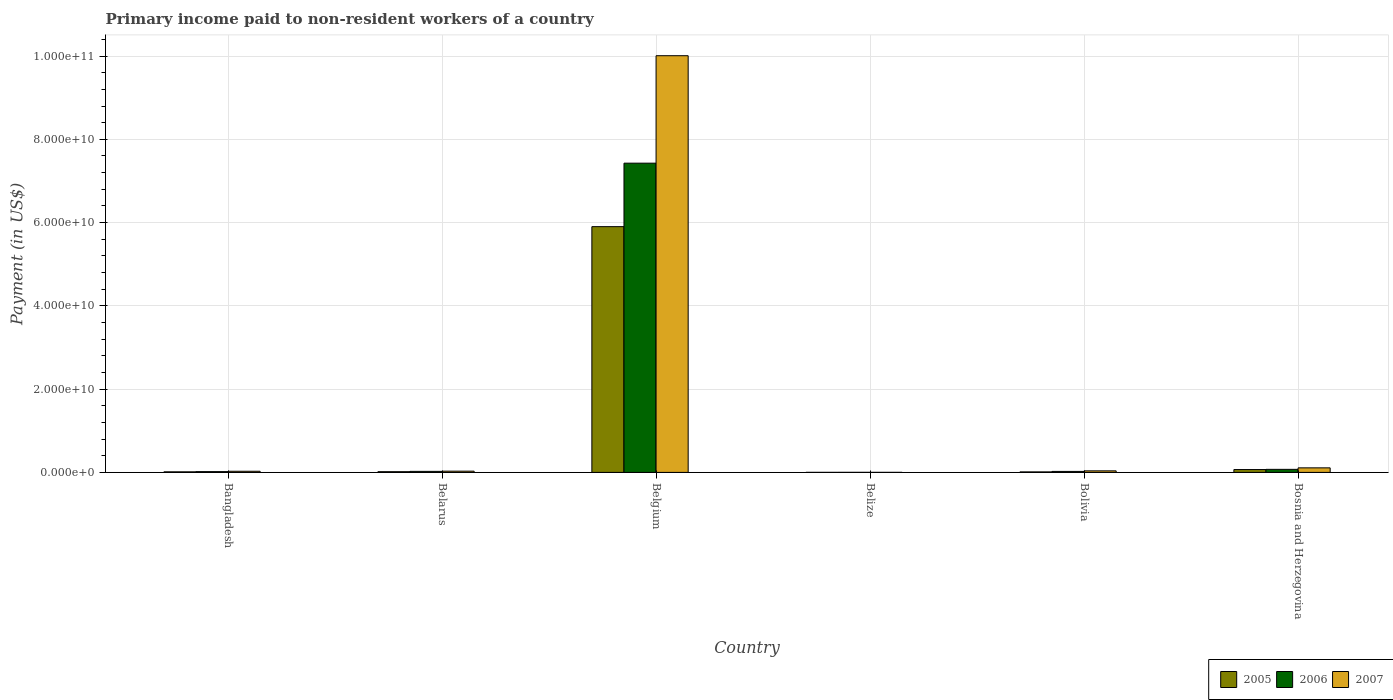How many different coloured bars are there?
Provide a succinct answer. 3. How many bars are there on the 4th tick from the left?
Offer a terse response. 3. How many bars are there on the 4th tick from the right?
Ensure brevity in your answer.  3. In how many cases, is the number of bars for a given country not equal to the number of legend labels?
Your response must be concise. 0. What is the amount paid to workers in 2007 in Bangladesh?
Your response must be concise. 2.72e+08. Across all countries, what is the maximum amount paid to workers in 2007?
Offer a very short reply. 1.00e+11. Across all countries, what is the minimum amount paid to workers in 2007?
Your response must be concise. 6.97e+06. In which country was the amount paid to workers in 2005 maximum?
Your answer should be very brief. Belgium. In which country was the amount paid to workers in 2005 minimum?
Your answer should be compact. Belize. What is the total amount paid to workers in 2007 in the graph?
Your response must be concise. 1.02e+11. What is the difference between the amount paid to workers in 2007 in Belize and that in Bolivia?
Ensure brevity in your answer.  -3.63e+08. What is the difference between the amount paid to workers in 2005 in Bolivia and the amount paid to workers in 2007 in Belarus?
Offer a terse response. -1.76e+08. What is the average amount paid to workers in 2006 per country?
Provide a short and direct response. 1.26e+1. What is the difference between the amount paid to workers of/in 2005 and amount paid to workers of/in 2007 in Bosnia and Herzegovina?
Make the answer very short. -4.10e+08. What is the ratio of the amount paid to workers in 2005 in Belarus to that in Bosnia and Herzegovina?
Provide a short and direct response. 0.25. Is the difference between the amount paid to workers in 2005 in Belgium and Bolivia greater than the difference between the amount paid to workers in 2007 in Belgium and Bolivia?
Your response must be concise. No. What is the difference between the highest and the second highest amount paid to workers in 2006?
Ensure brevity in your answer.  -7.40e+1. What is the difference between the highest and the lowest amount paid to workers in 2007?
Provide a succinct answer. 1.00e+11. Is the sum of the amount paid to workers in 2006 in Bolivia and Bosnia and Herzegovina greater than the maximum amount paid to workers in 2005 across all countries?
Offer a terse response. No. What does the 2nd bar from the left in Belarus represents?
Offer a terse response. 2006. Is it the case that in every country, the sum of the amount paid to workers in 2005 and amount paid to workers in 2006 is greater than the amount paid to workers in 2007?
Keep it short and to the point. No. How many bars are there?
Your answer should be compact. 18. Are all the bars in the graph horizontal?
Offer a very short reply. No. Does the graph contain any zero values?
Give a very brief answer. No. Does the graph contain grids?
Keep it short and to the point. Yes. What is the title of the graph?
Provide a short and direct response. Primary income paid to non-resident workers of a country. Does "1987" appear as one of the legend labels in the graph?
Your response must be concise. No. What is the label or title of the X-axis?
Give a very brief answer. Country. What is the label or title of the Y-axis?
Your answer should be very brief. Payment (in US$). What is the Payment (in US$) in 2005 in Bangladesh?
Your response must be concise. 1.35e+08. What is the Payment (in US$) in 2006 in Bangladesh?
Keep it short and to the point. 1.84e+08. What is the Payment (in US$) in 2007 in Bangladesh?
Your response must be concise. 2.72e+08. What is the Payment (in US$) of 2005 in Belarus?
Your answer should be compact. 1.68e+08. What is the Payment (in US$) in 2006 in Belarus?
Ensure brevity in your answer.  2.47e+08. What is the Payment (in US$) of 2007 in Belarus?
Provide a succinct answer. 2.97e+08. What is the Payment (in US$) of 2005 in Belgium?
Your answer should be very brief. 5.90e+1. What is the Payment (in US$) of 2006 in Belgium?
Your answer should be very brief. 7.43e+1. What is the Payment (in US$) of 2007 in Belgium?
Your answer should be compact. 1.00e+11. What is the Payment (in US$) of 2005 in Belize?
Your response must be concise. 6.78e+06. What is the Payment (in US$) of 2006 in Belize?
Provide a succinct answer. 1.01e+07. What is the Payment (in US$) of 2007 in Belize?
Your response must be concise. 6.97e+06. What is the Payment (in US$) in 2005 in Bolivia?
Keep it short and to the point. 1.21e+08. What is the Payment (in US$) in 2006 in Bolivia?
Provide a short and direct response. 2.35e+08. What is the Payment (in US$) of 2007 in Bolivia?
Provide a succinct answer. 3.70e+08. What is the Payment (in US$) of 2005 in Bosnia and Herzegovina?
Make the answer very short. 6.82e+08. What is the Payment (in US$) in 2006 in Bosnia and Herzegovina?
Offer a very short reply. 7.33e+08. What is the Payment (in US$) of 2007 in Bosnia and Herzegovina?
Give a very brief answer. 1.09e+09. Across all countries, what is the maximum Payment (in US$) of 2005?
Provide a succinct answer. 5.90e+1. Across all countries, what is the maximum Payment (in US$) in 2006?
Keep it short and to the point. 7.43e+1. Across all countries, what is the maximum Payment (in US$) of 2007?
Offer a very short reply. 1.00e+11. Across all countries, what is the minimum Payment (in US$) of 2005?
Give a very brief answer. 6.78e+06. Across all countries, what is the minimum Payment (in US$) in 2006?
Your answer should be very brief. 1.01e+07. Across all countries, what is the minimum Payment (in US$) in 2007?
Make the answer very short. 6.97e+06. What is the total Payment (in US$) of 2005 in the graph?
Offer a terse response. 6.01e+1. What is the total Payment (in US$) of 2006 in the graph?
Your answer should be compact. 7.57e+1. What is the total Payment (in US$) of 2007 in the graph?
Keep it short and to the point. 1.02e+11. What is the difference between the Payment (in US$) of 2005 in Bangladesh and that in Belarus?
Provide a succinct answer. -3.32e+07. What is the difference between the Payment (in US$) in 2006 in Bangladesh and that in Belarus?
Offer a terse response. -6.22e+07. What is the difference between the Payment (in US$) in 2007 in Bangladesh and that in Belarus?
Your answer should be compact. -2.54e+07. What is the difference between the Payment (in US$) of 2005 in Bangladesh and that in Belgium?
Give a very brief answer. -5.89e+1. What is the difference between the Payment (in US$) in 2006 in Bangladesh and that in Belgium?
Give a very brief answer. -7.41e+1. What is the difference between the Payment (in US$) of 2007 in Bangladesh and that in Belgium?
Ensure brevity in your answer.  -9.98e+1. What is the difference between the Payment (in US$) of 2005 in Bangladesh and that in Belize?
Offer a terse response. 1.28e+08. What is the difference between the Payment (in US$) of 2006 in Bangladesh and that in Belize?
Make the answer very short. 1.74e+08. What is the difference between the Payment (in US$) of 2007 in Bangladesh and that in Belize?
Ensure brevity in your answer.  2.65e+08. What is the difference between the Payment (in US$) of 2005 in Bangladesh and that in Bolivia?
Offer a very short reply. 1.39e+07. What is the difference between the Payment (in US$) in 2006 in Bangladesh and that in Bolivia?
Offer a terse response. -5.10e+07. What is the difference between the Payment (in US$) of 2007 in Bangladesh and that in Bolivia?
Offer a terse response. -9.81e+07. What is the difference between the Payment (in US$) of 2005 in Bangladesh and that in Bosnia and Herzegovina?
Ensure brevity in your answer.  -5.47e+08. What is the difference between the Payment (in US$) in 2006 in Bangladesh and that in Bosnia and Herzegovina?
Offer a terse response. -5.48e+08. What is the difference between the Payment (in US$) of 2007 in Bangladesh and that in Bosnia and Herzegovina?
Offer a terse response. -8.20e+08. What is the difference between the Payment (in US$) of 2005 in Belarus and that in Belgium?
Your answer should be compact. -5.89e+1. What is the difference between the Payment (in US$) in 2006 in Belarus and that in Belgium?
Ensure brevity in your answer.  -7.40e+1. What is the difference between the Payment (in US$) of 2007 in Belarus and that in Belgium?
Provide a short and direct response. -9.98e+1. What is the difference between the Payment (in US$) of 2005 in Belarus and that in Belize?
Offer a very short reply. 1.62e+08. What is the difference between the Payment (in US$) in 2006 in Belarus and that in Belize?
Ensure brevity in your answer.  2.36e+08. What is the difference between the Payment (in US$) of 2007 in Belarus and that in Belize?
Provide a short and direct response. 2.90e+08. What is the difference between the Payment (in US$) of 2005 in Belarus and that in Bolivia?
Ensure brevity in your answer.  4.72e+07. What is the difference between the Payment (in US$) of 2006 in Belarus and that in Bolivia?
Offer a very short reply. 1.12e+07. What is the difference between the Payment (in US$) in 2007 in Belarus and that in Bolivia?
Offer a terse response. -7.27e+07. What is the difference between the Payment (in US$) in 2005 in Belarus and that in Bosnia and Herzegovina?
Keep it short and to the point. -5.14e+08. What is the difference between the Payment (in US$) of 2006 in Belarus and that in Bosnia and Herzegovina?
Keep it short and to the point. -4.86e+08. What is the difference between the Payment (in US$) of 2007 in Belarus and that in Bosnia and Herzegovina?
Give a very brief answer. -7.95e+08. What is the difference between the Payment (in US$) in 2005 in Belgium and that in Belize?
Your answer should be compact. 5.90e+1. What is the difference between the Payment (in US$) of 2006 in Belgium and that in Belize?
Provide a succinct answer. 7.43e+1. What is the difference between the Payment (in US$) in 2007 in Belgium and that in Belize?
Ensure brevity in your answer.  1.00e+11. What is the difference between the Payment (in US$) in 2005 in Belgium and that in Bolivia?
Provide a succinct answer. 5.89e+1. What is the difference between the Payment (in US$) in 2006 in Belgium and that in Bolivia?
Make the answer very short. 7.40e+1. What is the difference between the Payment (in US$) of 2007 in Belgium and that in Bolivia?
Provide a short and direct response. 9.97e+1. What is the difference between the Payment (in US$) in 2005 in Belgium and that in Bosnia and Herzegovina?
Your answer should be very brief. 5.83e+1. What is the difference between the Payment (in US$) of 2006 in Belgium and that in Bosnia and Herzegovina?
Your response must be concise. 7.35e+1. What is the difference between the Payment (in US$) of 2007 in Belgium and that in Bosnia and Herzegovina?
Your answer should be very brief. 9.90e+1. What is the difference between the Payment (in US$) in 2005 in Belize and that in Bolivia?
Give a very brief answer. -1.14e+08. What is the difference between the Payment (in US$) of 2006 in Belize and that in Bolivia?
Provide a short and direct response. -2.25e+08. What is the difference between the Payment (in US$) of 2007 in Belize and that in Bolivia?
Make the answer very short. -3.63e+08. What is the difference between the Payment (in US$) of 2005 in Belize and that in Bosnia and Herzegovina?
Give a very brief answer. -6.76e+08. What is the difference between the Payment (in US$) of 2006 in Belize and that in Bosnia and Herzegovina?
Keep it short and to the point. -7.22e+08. What is the difference between the Payment (in US$) of 2007 in Belize and that in Bosnia and Herzegovina?
Offer a terse response. -1.08e+09. What is the difference between the Payment (in US$) of 2005 in Bolivia and that in Bosnia and Herzegovina?
Your answer should be compact. -5.61e+08. What is the difference between the Payment (in US$) of 2006 in Bolivia and that in Bosnia and Herzegovina?
Ensure brevity in your answer.  -4.97e+08. What is the difference between the Payment (in US$) of 2007 in Bolivia and that in Bosnia and Herzegovina?
Your response must be concise. -7.22e+08. What is the difference between the Payment (in US$) of 2005 in Bangladesh and the Payment (in US$) of 2006 in Belarus?
Give a very brief answer. -1.11e+08. What is the difference between the Payment (in US$) in 2005 in Bangladesh and the Payment (in US$) in 2007 in Belarus?
Make the answer very short. -1.62e+08. What is the difference between the Payment (in US$) in 2006 in Bangladesh and the Payment (in US$) in 2007 in Belarus?
Ensure brevity in your answer.  -1.13e+08. What is the difference between the Payment (in US$) of 2005 in Bangladesh and the Payment (in US$) of 2006 in Belgium?
Offer a terse response. -7.41e+1. What is the difference between the Payment (in US$) in 2005 in Bangladesh and the Payment (in US$) in 2007 in Belgium?
Give a very brief answer. -1.00e+11. What is the difference between the Payment (in US$) of 2006 in Bangladesh and the Payment (in US$) of 2007 in Belgium?
Provide a short and direct response. -9.99e+1. What is the difference between the Payment (in US$) in 2005 in Bangladesh and the Payment (in US$) in 2006 in Belize?
Your answer should be compact. 1.25e+08. What is the difference between the Payment (in US$) in 2005 in Bangladesh and the Payment (in US$) in 2007 in Belize?
Make the answer very short. 1.28e+08. What is the difference between the Payment (in US$) in 2006 in Bangladesh and the Payment (in US$) in 2007 in Belize?
Offer a terse response. 1.77e+08. What is the difference between the Payment (in US$) in 2005 in Bangladesh and the Payment (in US$) in 2006 in Bolivia?
Make the answer very short. -1.00e+08. What is the difference between the Payment (in US$) in 2005 in Bangladesh and the Payment (in US$) in 2007 in Bolivia?
Keep it short and to the point. -2.35e+08. What is the difference between the Payment (in US$) in 2006 in Bangladesh and the Payment (in US$) in 2007 in Bolivia?
Give a very brief answer. -1.85e+08. What is the difference between the Payment (in US$) of 2005 in Bangladesh and the Payment (in US$) of 2006 in Bosnia and Herzegovina?
Keep it short and to the point. -5.97e+08. What is the difference between the Payment (in US$) of 2005 in Bangladesh and the Payment (in US$) of 2007 in Bosnia and Herzegovina?
Your response must be concise. -9.57e+08. What is the difference between the Payment (in US$) in 2006 in Bangladesh and the Payment (in US$) in 2007 in Bosnia and Herzegovina?
Offer a terse response. -9.07e+08. What is the difference between the Payment (in US$) in 2005 in Belarus and the Payment (in US$) in 2006 in Belgium?
Provide a short and direct response. -7.41e+1. What is the difference between the Payment (in US$) in 2005 in Belarus and the Payment (in US$) in 2007 in Belgium?
Offer a very short reply. -9.99e+1. What is the difference between the Payment (in US$) of 2006 in Belarus and the Payment (in US$) of 2007 in Belgium?
Ensure brevity in your answer.  -9.98e+1. What is the difference between the Payment (in US$) of 2005 in Belarus and the Payment (in US$) of 2006 in Belize?
Make the answer very short. 1.58e+08. What is the difference between the Payment (in US$) of 2005 in Belarus and the Payment (in US$) of 2007 in Belize?
Your answer should be very brief. 1.61e+08. What is the difference between the Payment (in US$) of 2006 in Belarus and the Payment (in US$) of 2007 in Belize?
Keep it short and to the point. 2.40e+08. What is the difference between the Payment (in US$) in 2005 in Belarus and the Payment (in US$) in 2006 in Bolivia?
Offer a terse response. -6.70e+07. What is the difference between the Payment (in US$) in 2005 in Belarus and the Payment (in US$) in 2007 in Bolivia?
Provide a succinct answer. -2.01e+08. What is the difference between the Payment (in US$) of 2006 in Belarus and the Payment (in US$) of 2007 in Bolivia?
Ensure brevity in your answer.  -1.23e+08. What is the difference between the Payment (in US$) in 2005 in Belarus and the Payment (in US$) in 2006 in Bosnia and Herzegovina?
Keep it short and to the point. -5.64e+08. What is the difference between the Payment (in US$) in 2005 in Belarus and the Payment (in US$) in 2007 in Bosnia and Herzegovina?
Your answer should be very brief. -9.23e+08. What is the difference between the Payment (in US$) in 2006 in Belarus and the Payment (in US$) in 2007 in Bosnia and Herzegovina?
Offer a very short reply. -8.45e+08. What is the difference between the Payment (in US$) in 2005 in Belgium and the Payment (in US$) in 2006 in Belize?
Your answer should be compact. 5.90e+1. What is the difference between the Payment (in US$) of 2005 in Belgium and the Payment (in US$) of 2007 in Belize?
Give a very brief answer. 5.90e+1. What is the difference between the Payment (in US$) of 2006 in Belgium and the Payment (in US$) of 2007 in Belize?
Provide a succinct answer. 7.43e+1. What is the difference between the Payment (in US$) of 2005 in Belgium and the Payment (in US$) of 2006 in Bolivia?
Your answer should be very brief. 5.88e+1. What is the difference between the Payment (in US$) in 2005 in Belgium and the Payment (in US$) in 2007 in Bolivia?
Give a very brief answer. 5.87e+1. What is the difference between the Payment (in US$) in 2006 in Belgium and the Payment (in US$) in 2007 in Bolivia?
Your response must be concise. 7.39e+1. What is the difference between the Payment (in US$) of 2005 in Belgium and the Payment (in US$) of 2006 in Bosnia and Herzegovina?
Your response must be concise. 5.83e+1. What is the difference between the Payment (in US$) of 2005 in Belgium and the Payment (in US$) of 2007 in Bosnia and Herzegovina?
Make the answer very short. 5.79e+1. What is the difference between the Payment (in US$) in 2006 in Belgium and the Payment (in US$) in 2007 in Bosnia and Herzegovina?
Your response must be concise. 7.32e+1. What is the difference between the Payment (in US$) of 2005 in Belize and the Payment (in US$) of 2006 in Bolivia?
Your response must be concise. -2.29e+08. What is the difference between the Payment (in US$) of 2005 in Belize and the Payment (in US$) of 2007 in Bolivia?
Give a very brief answer. -3.63e+08. What is the difference between the Payment (in US$) in 2006 in Belize and the Payment (in US$) in 2007 in Bolivia?
Give a very brief answer. -3.60e+08. What is the difference between the Payment (in US$) in 2005 in Belize and the Payment (in US$) in 2006 in Bosnia and Herzegovina?
Keep it short and to the point. -7.26e+08. What is the difference between the Payment (in US$) in 2005 in Belize and the Payment (in US$) in 2007 in Bosnia and Herzegovina?
Make the answer very short. -1.09e+09. What is the difference between the Payment (in US$) in 2006 in Belize and the Payment (in US$) in 2007 in Bosnia and Herzegovina?
Offer a very short reply. -1.08e+09. What is the difference between the Payment (in US$) of 2005 in Bolivia and the Payment (in US$) of 2006 in Bosnia and Herzegovina?
Make the answer very short. -6.11e+08. What is the difference between the Payment (in US$) of 2005 in Bolivia and the Payment (in US$) of 2007 in Bosnia and Herzegovina?
Your answer should be very brief. -9.71e+08. What is the difference between the Payment (in US$) of 2006 in Bolivia and the Payment (in US$) of 2007 in Bosnia and Herzegovina?
Provide a succinct answer. -8.56e+08. What is the average Payment (in US$) of 2005 per country?
Your response must be concise. 1.00e+1. What is the average Payment (in US$) in 2006 per country?
Your answer should be very brief. 1.26e+1. What is the average Payment (in US$) of 2007 per country?
Your answer should be very brief. 1.70e+1. What is the difference between the Payment (in US$) in 2005 and Payment (in US$) in 2006 in Bangladesh?
Offer a terse response. -4.93e+07. What is the difference between the Payment (in US$) in 2005 and Payment (in US$) in 2007 in Bangladesh?
Keep it short and to the point. -1.37e+08. What is the difference between the Payment (in US$) in 2006 and Payment (in US$) in 2007 in Bangladesh?
Make the answer very short. -8.73e+07. What is the difference between the Payment (in US$) in 2005 and Payment (in US$) in 2006 in Belarus?
Keep it short and to the point. -7.82e+07. What is the difference between the Payment (in US$) in 2005 and Payment (in US$) in 2007 in Belarus?
Your answer should be very brief. -1.29e+08. What is the difference between the Payment (in US$) of 2006 and Payment (in US$) of 2007 in Belarus?
Your answer should be compact. -5.05e+07. What is the difference between the Payment (in US$) of 2005 and Payment (in US$) of 2006 in Belgium?
Give a very brief answer. -1.52e+1. What is the difference between the Payment (in US$) of 2005 and Payment (in US$) of 2007 in Belgium?
Give a very brief answer. -4.11e+1. What is the difference between the Payment (in US$) of 2006 and Payment (in US$) of 2007 in Belgium?
Provide a succinct answer. -2.58e+1. What is the difference between the Payment (in US$) of 2005 and Payment (in US$) of 2006 in Belize?
Provide a short and direct response. -3.32e+06. What is the difference between the Payment (in US$) in 2005 and Payment (in US$) in 2007 in Belize?
Your answer should be very brief. -1.86e+05. What is the difference between the Payment (in US$) of 2006 and Payment (in US$) of 2007 in Belize?
Provide a short and direct response. 3.13e+06. What is the difference between the Payment (in US$) of 2005 and Payment (in US$) of 2006 in Bolivia?
Your answer should be very brief. -1.14e+08. What is the difference between the Payment (in US$) in 2005 and Payment (in US$) in 2007 in Bolivia?
Your response must be concise. -2.49e+08. What is the difference between the Payment (in US$) in 2006 and Payment (in US$) in 2007 in Bolivia?
Ensure brevity in your answer.  -1.34e+08. What is the difference between the Payment (in US$) in 2005 and Payment (in US$) in 2006 in Bosnia and Herzegovina?
Provide a succinct answer. -5.03e+07. What is the difference between the Payment (in US$) of 2005 and Payment (in US$) of 2007 in Bosnia and Herzegovina?
Your answer should be very brief. -4.10e+08. What is the difference between the Payment (in US$) of 2006 and Payment (in US$) of 2007 in Bosnia and Herzegovina?
Provide a succinct answer. -3.59e+08. What is the ratio of the Payment (in US$) of 2005 in Bangladesh to that in Belarus?
Provide a succinct answer. 0.8. What is the ratio of the Payment (in US$) in 2006 in Bangladesh to that in Belarus?
Ensure brevity in your answer.  0.75. What is the ratio of the Payment (in US$) in 2007 in Bangladesh to that in Belarus?
Offer a terse response. 0.91. What is the ratio of the Payment (in US$) of 2005 in Bangladesh to that in Belgium?
Ensure brevity in your answer.  0. What is the ratio of the Payment (in US$) in 2006 in Bangladesh to that in Belgium?
Your answer should be compact. 0. What is the ratio of the Payment (in US$) in 2007 in Bangladesh to that in Belgium?
Provide a short and direct response. 0. What is the ratio of the Payment (in US$) of 2005 in Bangladesh to that in Belize?
Offer a very short reply. 19.93. What is the ratio of the Payment (in US$) in 2006 in Bangladesh to that in Belize?
Keep it short and to the point. 18.26. What is the ratio of the Payment (in US$) in 2007 in Bangladesh to that in Belize?
Your answer should be compact. 39. What is the ratio of the Payment (in US$) of 2005 in Bangladesh to that in Bolivia?
Provide a short and direct response. 1.11. What is the ratio of the Payment (in US$) of 2006 in Bangladesh to that in Bolivia?
Ensure brevity in your answer.  0.78. What is the ratio of the Payment (in US$) in 2007 in Bangladesh to that in Bolivia?
Your answer should be compact. 0.73. What is the ratio of the Payment (in US$) in 2005 in Bangladesh to that in Bosnia and Herzegovina?
Keep it short and to the point. 0.2. What is the ratio of the Payment (in US$) in 2006 in Bangladesh to that in Bosnia and Herzegovina?
Offer a terse response. 0.25. What is the ratio of the Payment (in US$) of 2007 in Bangladesh to that in Bosnia and Herzegovina?
Your response must be concise. 0.25. What is the ratio of the Payment (in US$) in 2005 in Belarus to that in Belgium?
Your response must be concise. 0. What is the ratio of the Payment (in US$) in 2006 in Belarus to that in Belgium?
Offer a terse response. 0. What is the ratio of the Payment (in US$) in 2007 in Belarus to that in Belgium?
Provide a short and direct response. 0. What is the ratio of the Payment (in US$) in 2005 in Belarus to that in Belize?
Your answer should be compact. 24.83. What is the ratio of the Payment (in US$) in 2006 in Belarus to that in Belize?
Your answer should be compact. 24.41. What is the ratio of the Payment (in US$) of 2007 in Belarus to that in Belize?
Offer a very short reply. 42.65. What is the ratio of the Payment (in US$) in 2005 in Belarus to that in Bolivia?
Give a very brief answer. 1.39. What is the ratio of the Payment (in US$) in 2006 in Belarus to that in Bolivia?
Keep it short and to the point. 1.05. What is the ratio of the Payment (in US$) in 2007 in Belarus to that in Bolivia?
Your answer should be very brief. 0.8. What is the ratio of the Payment (in US$) in 2005 in Belarus to that in Bosnia and Herzegovina?
Ensure brevity in your answer.  0.25. What is the ratio of the Payment (in US$) in 2006 in Belarus to that in Bosnia and Herzegovina?
Give a very brief answer. 0.34. What is the ratio of the Payment (in US$) in 2007 in Belarus to that in Bosnia and Herzegovina?
Give a very brief answer. 0.27. What is the ratio of the Payment (in US$) of 2005 in Belgium to that in Belize?
Provide a short and direct response. 8704.96. What is the ratio of the Payment (in US$) in 2006 in Belgium to that in Belize?
Provide a succinct answer. 7353.89. What is the ratio of the Payment (in US$) of 2007 in Belgium to that in Belize?
Your answer should be compact. 1.44e+04. What is the ratio of the Payment (in US$) of 2005 in Belgium to that in Bolivia?
Give a very brief answer. 486.92. What is the ratio of the Payment (in US$) of 2006 in Belgium to that in Bolivia?
Make the answer very short. 315.48. What is the ratio of the Payment (in US$) in 2007 in Belgium to that in Bolivia?
Keep it short and to the point. 270.62. What is the ratio of the Payment (in US$) of 2005 in Belgium to that in Bosnia and Herzegovina?
Keep it short and to the point. 86.51. What is the ratio of the Payment (in US$) of 2006 in Belgium to that in Bosnia and Herzegovina?
Provide a short and direct response. 101.39. What is the ratio of the Payment (in US$) of 2007 in Belgium to that in Bosnia and Herzegovina?
Your response must be concise. 91.66. What is the ratio of the Payment (in US$) in 2005 in Belize to that in Bolivia?
Provide a short and direct response. 0.06. What is the ratio of the Payment (in US$) in 2006 in Belize to that in Bolivia?
Ensure brevity in your answer.  0.04. What is the ratio of the Payment (in US$) of 2007 in Belize to that in Bolivia?
Your answer should be compact. 0.02. What is the ratio of the Payment (in US$) in 2005 in Belize to that in Bosnia and Herzegovina?
Provide a short and direct response. 0.01. What is the ratio of the Payment (in US$) of 2006 in Belize to that in Bosnia and Herzegovina?
Provide a succinct answer. 0.01. What is the ratio of the Payment (in US$) of 2007 in Belize to that in Bosnia and Herzegovina?
Provide a succinct answer. 0.01. What is the ratio of the Payment (in US$) of 2005 in Bolivia to that in Bosnia and Herzegovina?
Give a very brief answer. 0.18. What is the ratio of the Payment (in US$) of 2006 in Bolivia to that in Bosnia and Herzegovina?
Your answer should be very brief. 0.32. What is the ratio of the Payment (in US$) of 2007 in Bolivia to that in Bosnia and Herzegovina?
Ensure brevity in your answer.  0.34. What is the difference between the highest and the second highest Payment (in US$) in 2005?
Offer a terse response. 5.83e+1. What is the difference between the highest and the second highest Payment (in US$) in 2006?
Your response must be concise. 7.35e+1. What is the difference between the highest and the second highest Payment (in US$) in 2007?
Provide a short and direct response. 9.90e+1. What is the difference between the highest and the lowest Payment (in US$) in 2005?
Keep it short and to the point. 5.90e+1. What is the difference between the highest and the lowest Payment (in US$) in 2006?
Your answer should be compact. 7.43e+1. What is the difference between the highest and the lowest Payment (in US$) in 2007?
Keep it short and to the point. 1.00e+11. 